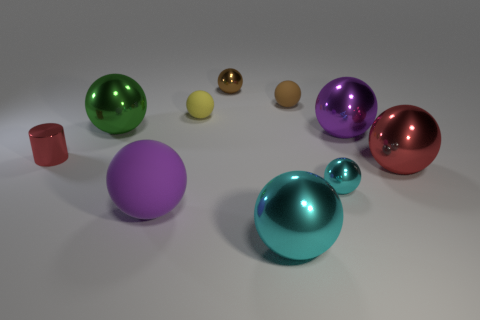Are there any big shiny objects that have the same color as the big rubber thing?
Offer a terse response. Yes. What is the size of the sphere that is the same color as the metallic cylinder?
Give a very brief answer. Large. How many objects are red cylinders or metal balls that are in front of the red cylinder?
Your response must be concise. 4. There is a purple sphere that is made of the same material as the large red sphere; what size is it?
Make the answer very short. Large. What is the shape of the tiny object that is left of the rubber ball that is in front of the big green metallic object?
Offer a very short reply. Cylinder. What number of yellow things are small shiny balls or large balls?
Your response must be concise. 0. There is a red object behind the red object that is to the right of the big rubber sphere; are there any large metal things in front of it?
Provide a short and direct response. Yes. What is the shape of the large thing that is the same color as the big matte ball?
Make the answer very short. Sphere. How many tiny objects are shiny things or purple matte spheres?
Your response must be concise. 3. There is a large purple object behind the tiny red cylinder; is its shape the same as the purple rubber thing?
Your answer should be compact. Yes. 